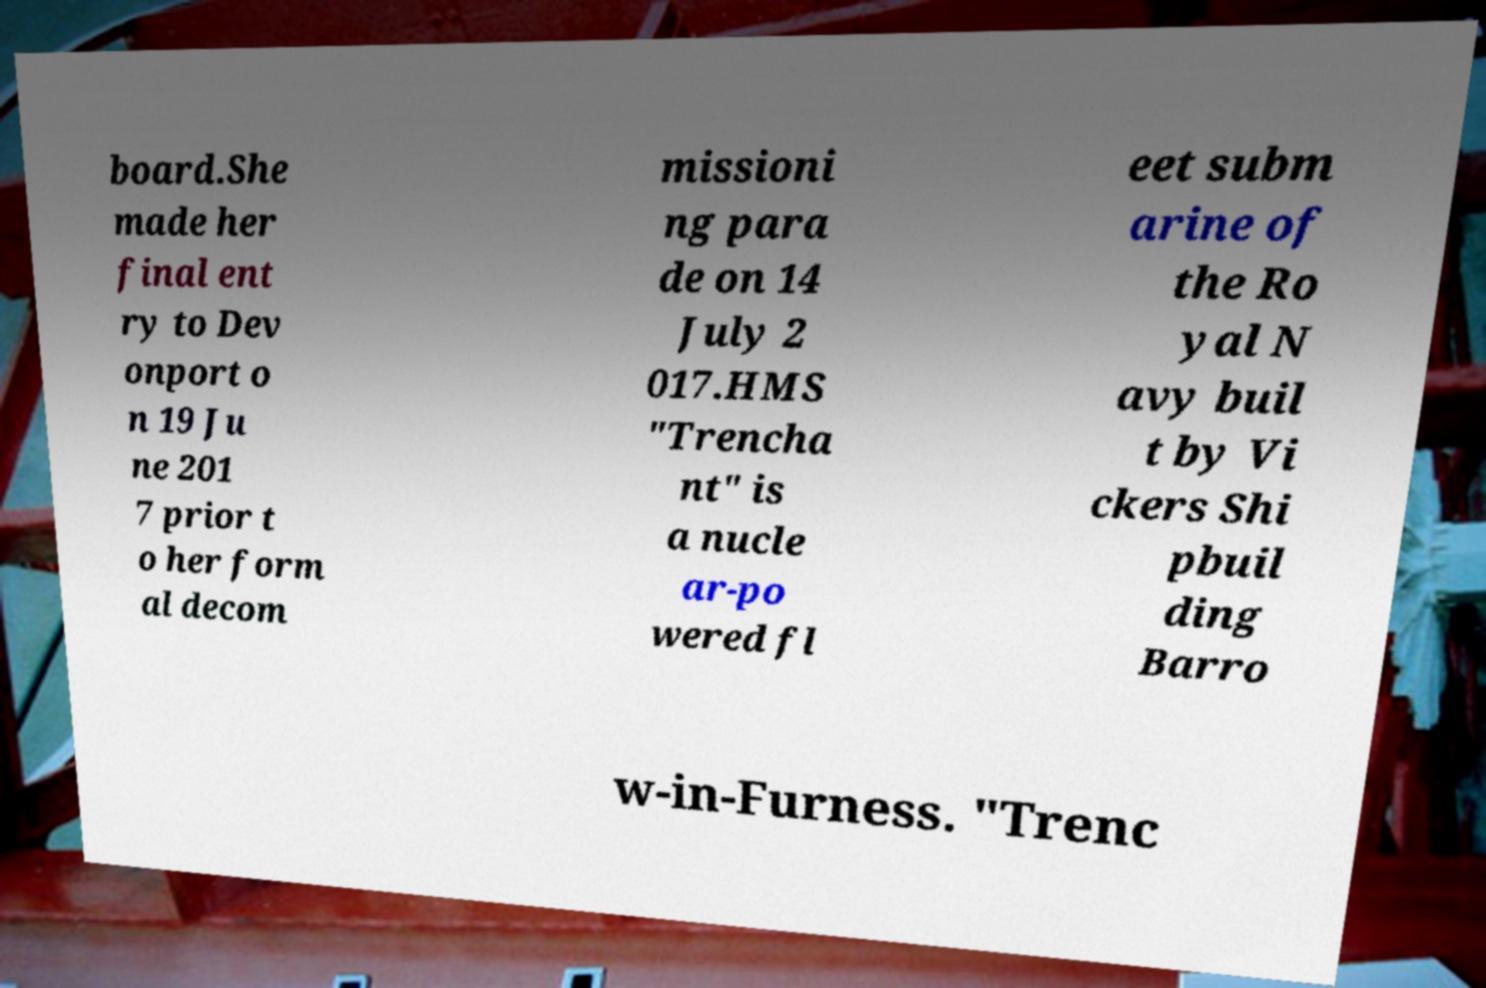Can you accurately transcribe the text from the provided image for me? board.She made her final ent ry to Dev onport o n 19 Ju ne 201 7 prior t o her form al decom missioni ng para de on 14 July 2 017.HMS "Trencha nt" is a nucle ar-po wered fl eet subm arine of the Ro yal N avy buil t by Vi ckers Shi pbuil ding Barro w-in-Furness. "Trenc 